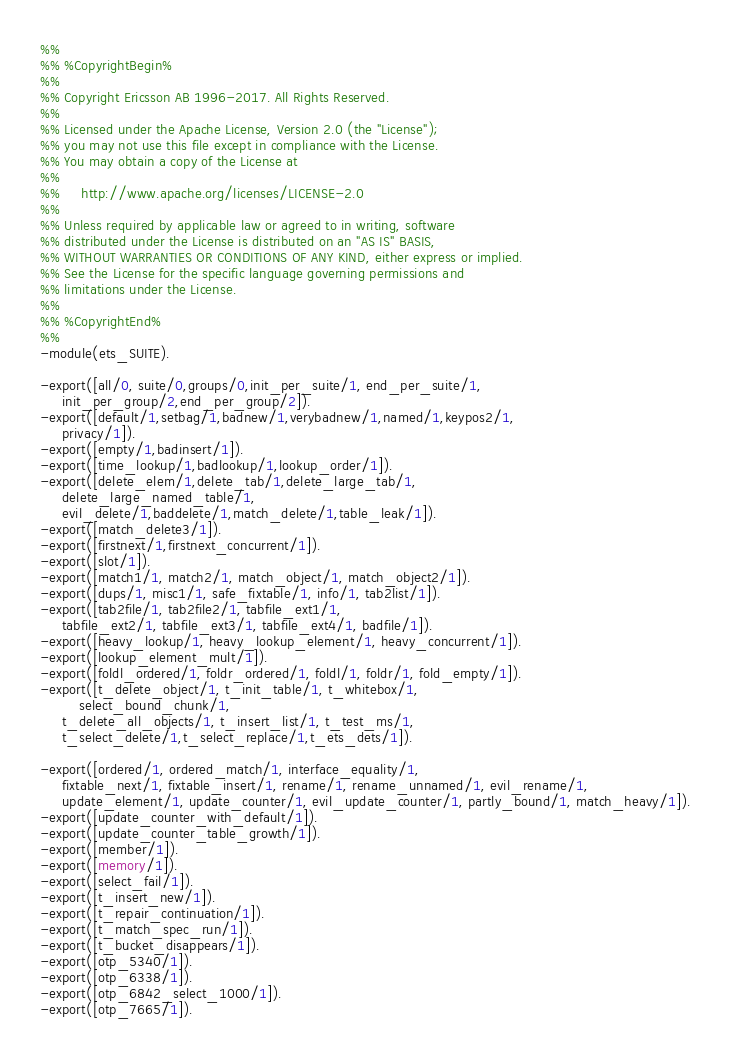Convert code to text. <code><loc_0><loc_0><loc_500><loc_500><_Erlang_>%%
%% %CopyrightBegin%
%%
%% Copyright Ericsson AB 1996-2017. All Rights Reserved.
%%
%% Licensed under the Apache License, Version 2.0 (the "License");
%% you may not use this file except in compliance with the License.
%% You may obtain a copy of the License at
%%
%%     http://www.apache.org/licenses/LICENSE-2.0
%%
%% Unless required by applicable law or agreed to in writing, software
%% distributed under the License is distributed on an "AS IS" BASIS,
%% WITHOUT WARRANTIES OR CONDITIONS OF ANY KIND, either express or implied.
%% See the License for the specific language governing permissions and
%% limitations under the License.
%%
%% %CopyrightEnd%
%%
-module(ets_SUITE).

-export([all/0, suite/0,groups/0,init_per_suite/1, end_per_suite/1,
	 init_per_group/2,end_per_group/2]).
-export([default/1,setbag/1,badnew/1,verybadnew/1,named/1,keypos2/1,
	 privacy/1]).
-export([empty/1,badinsert/1]).
-export([time_lookup/1,badlookup/1,lookup_order/1]).
-export([delete_elem/1,delete_tab/1,delete_large_tab/1,
	 delete_large_named_table/1,
	 evil_delete/1,baddelete/1,match_delete/1,table_leak/1]).
-export([match_delete3/1]).
-export([firstnext/1,firstnext_concurrent/1]).
-export([slot/1]).
-export([match1/1, match2/1, match_object/1, match_object2/1]).
-export([dups/1, misc1/1, safe_fixtable/1, info/1, tab2list/1]).
-export([tab2file/1, tab2file2/1, tabfile_ext1/1,
	 tabfile_ext2/1, tabfile_ext3/1, tabfile_ext4/1, badfile/1]).
-export([heavy_lookup/1, heavy_lookup_element/1, heavy_concurrent/1]).
-export([lookup_element_mult/1]).
-export([foldl_ordered/1, foldr_ordered/1, foldl/1, foldr/1, fold_empty/1]).
-export([t_delete_object/1, t_init_table/1, t_whitebox/1,
         select_bound_chunk/1,
	 t_delete_all_objects/1, t_insert_list/1, t_test_ms/1,
	 t_select_delete/1,t_select_replace/1,t_ets_dets/1]).

-export([ordered/1, ordered_match/1, interface_equality/1,
	 fixtable_next/1, fixtable_insert/1, rename/1, rename_unnamed/1, evil_rename/1,
	 update_element/1, update_counter/1, evil_update_counter/1, partly_bound/1, match_heavy/1]).
-export([update_counter_with_default/1]).
-export([update_counter_table_growth/1]).
-export([member/1]).
-export([memory/1]).
-export([select_fail/1]).
-export([t_insert_new/1]).
-export([t_repair_continuation/1]).
-export([t_match_spec_run/1]).
-export([t_bucket_disappears/1]).
-export([otp_5340/1]).
-export([otp_6338/1]).
-export([otp_6842_select_1000/1]).
-export([otp_7665/1]).</code> 